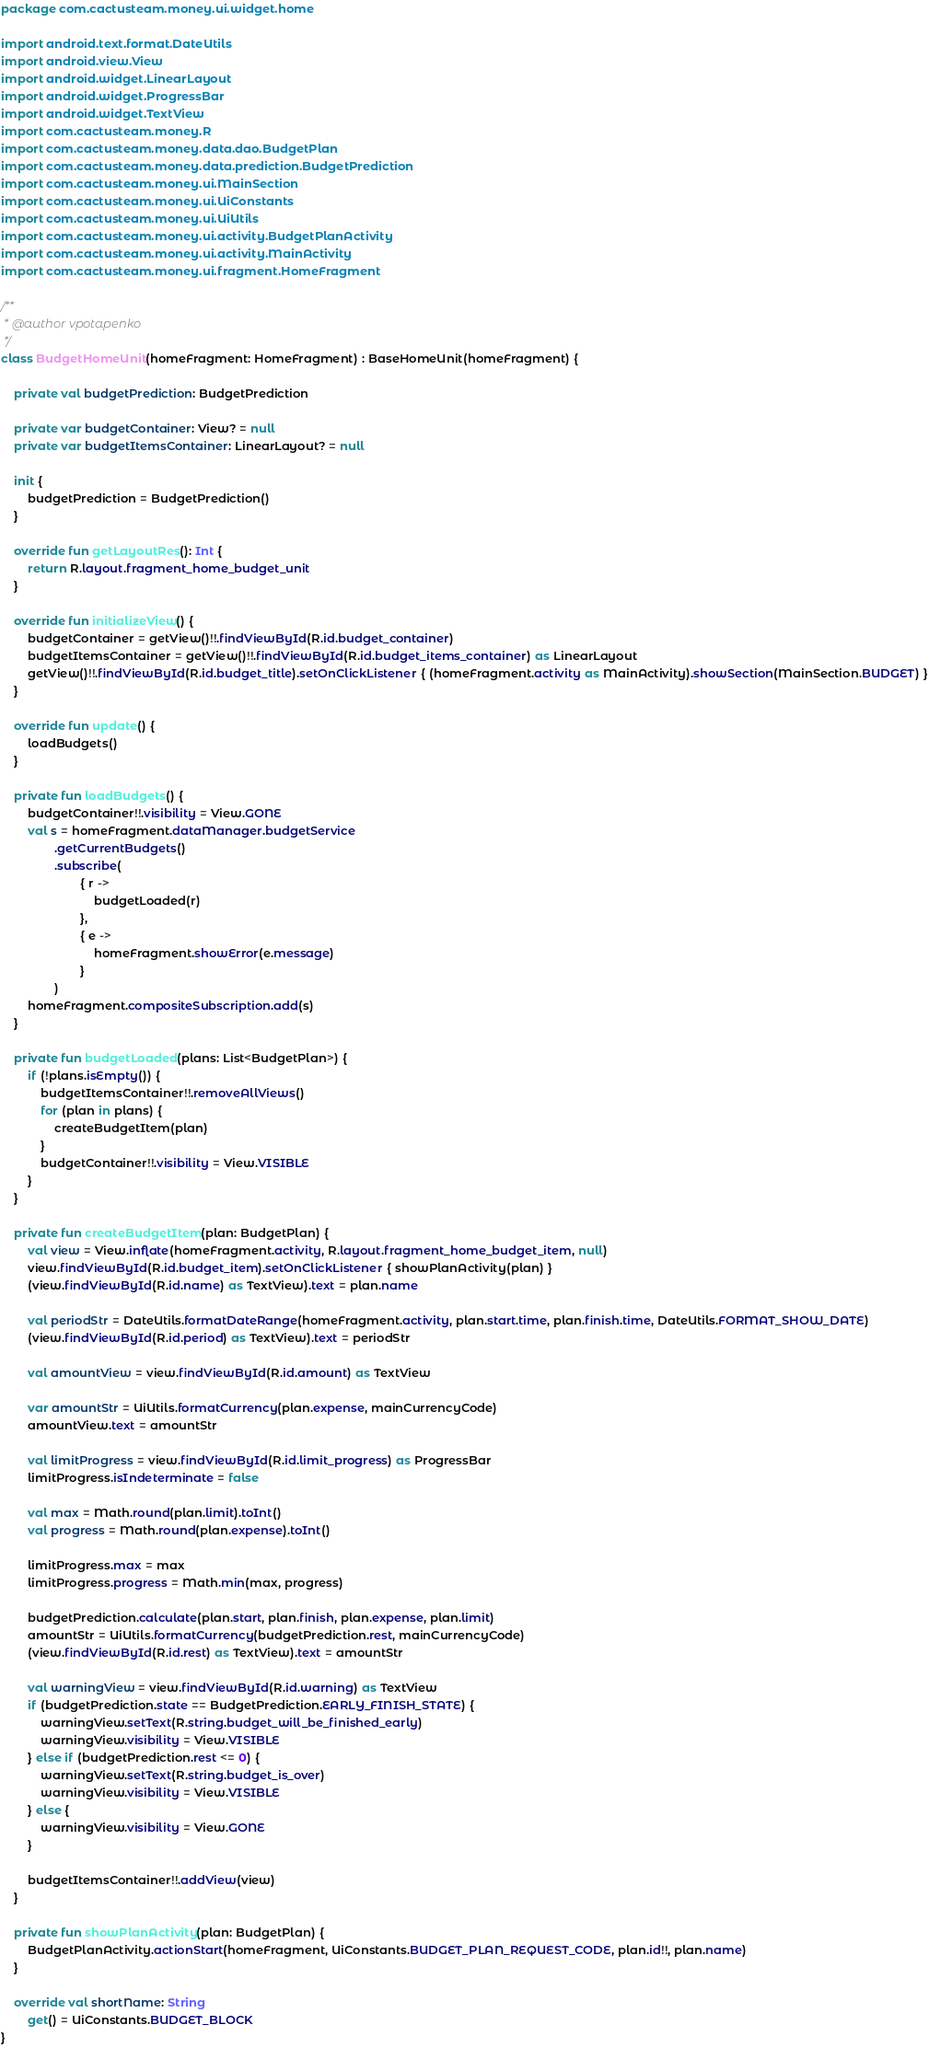Convert code to text. <code><loc_0><loc_0><loc_500><loc_500><_Kotlin_>package com.cactusteam.money.ui.widget.home

import android.text.format.DateUtils
import android.view.View
import android.widget.LinearLayout
import android.widget.ProgressBar
import android.widget.TextView
import com.cactusteam.money.R
import com.cactusteam.money.data.dao.BudgetPlan
import com.cactusteam.money.data.prediction.BudgetPrediction
import com.cactusteam.money.ui.MainSection
import com.cactusteam.money.ui.UiConstants
import com.cactusteam.money.ui.UiUtils
import com.cactusteam.money.ui.activity.BudgetPlanActivity
import com.cactusteam.money.ui.activity.MainActivity
import com.cactusteam.money.ui.fragment.HomeFragment

/**
 * @author vpotapenko
 */
class BudgetHomeUnit(homeFragment: HomeFragment) : BaseHomeUnit(homeFragment) {

    private val budgetPrediction: BudgetPrediction

    private var budgetContainer: View? = null
    private var budgetItemsContainer: LinearLayout? = null

    init {
        budgetPrediction = BudgetPrediction()
    }

    override fun getLayoutRes(): Int {
        return R.layout.fragment_home_budget_unit
    }

    override fun initializeView() {
        budgetContainer = getView()!!.findViewById(R.id.budget_container)
        budgetItemsContainer = getView()!!.findViewById(R.id.budget_items_container) as LinearLayout
        getView()!!.findViewById(R.id.budget_title).setOnClickListener { (homeFragment.activity as MainActivity).showSection(MainSection.BUDGET) }
    }

    override fun update() {
        loadBudgets()
    }

    private fun loadBudgets() {
        budgetContainer!!.visibility = View.GONE
        val s = homeFragment.dataManager.budgetService
                .getCurrentBudgets()
                .subscribe(
                        { r ->
                            budgetLoaded(r)
                        },
                        { e ->
                            homeFragment.showError(e.message)
                        }
                )
        homeFragment.compositeSubscription.add(s)
    }

    private fun budgetLoaded(plans: List<BudgetPlan>) {
        if (!plans.isEmpty()) {
            budgetItemsContainer!!.removeAllViews()
            for (plan in plans) {
                createBudgetItem(plan)
            }
            budgetContainer!!.visibility = View.VISIBLE
        }
    }

    private fun createBudgetItem(plan: BudgetPlan) {
        val view = View.inflate(homeFragment.activity, R.layout.fragment_home_budget_item, null)
        view.findViewById(R.id.budget_item).setOnClickListener { showPlanActivity(plan) }
        (view.findViewById(R.id.name) as TextView).text = plan.name

        val periodStr = DateUtils.formatDateRange(homeFragment.activity, plan.start.time, plan.finish.time, DateUtils.FORMAT_SHOW_DATE)
        (view.findViewById(R.id.period) as TextView).text = periodStr

        val amountView = view.findViewById(R.id.amount) as TextView

        var amountStr = UiUtils.formatCurrency(plan.expense, mainCurrencyCode)
        amountView.text = amountStr

        val limitProgress = view.findViewById(R.id.limit_progress) as ProgressBar
        limitProgress.isIndeterminate = false

        val max = Math.round(plan.limit).toInt()
        val progress = Math.round(plan.expense).toInt()

        limitProgress.max = max
        limitProgress.progress = Math.min(max, progress)

        budgetPrediction.calculate(plan.start, plan.finish, plan.expense, plan.limit)
        amountStr = UiUtils.formatCurrency(budgetPrediction.rest, mainCurrencyCode)
        (view.findViewById(R.id.rest) as TextView).text = amountStr

        val warningView = view.findViewById(R.id.warning) as TextView
        if (budgetPrediction.state == BudgetPrediction.EARLY_FINISH_STATE) {
            warningView.setText(R.string.budget_will_be_finished_early)
            warningView.visibility = View.VISIBLE
        } else if (budgetPrediction.rest <= 0) {
            warningView.setText(R.string.budget_is_over)
            warningView.visibility = View.VISIBLE
        } else {
            warningView.visibility = View.GONE
        }

        budgetItemsContainer!!.addView(view)
    }

    private fun showPlanActivity(plan: BudgetPlan) {
        BudgetPlanActivity.actionStart(homeFragment, UiConstants.BUDGET_PLAN_REQUEST_CODE, plan.id!!, plan.name)
    }

    override val shortName: String
        get() = UiConstants.BUDGET_BLOCK
}
</code> 